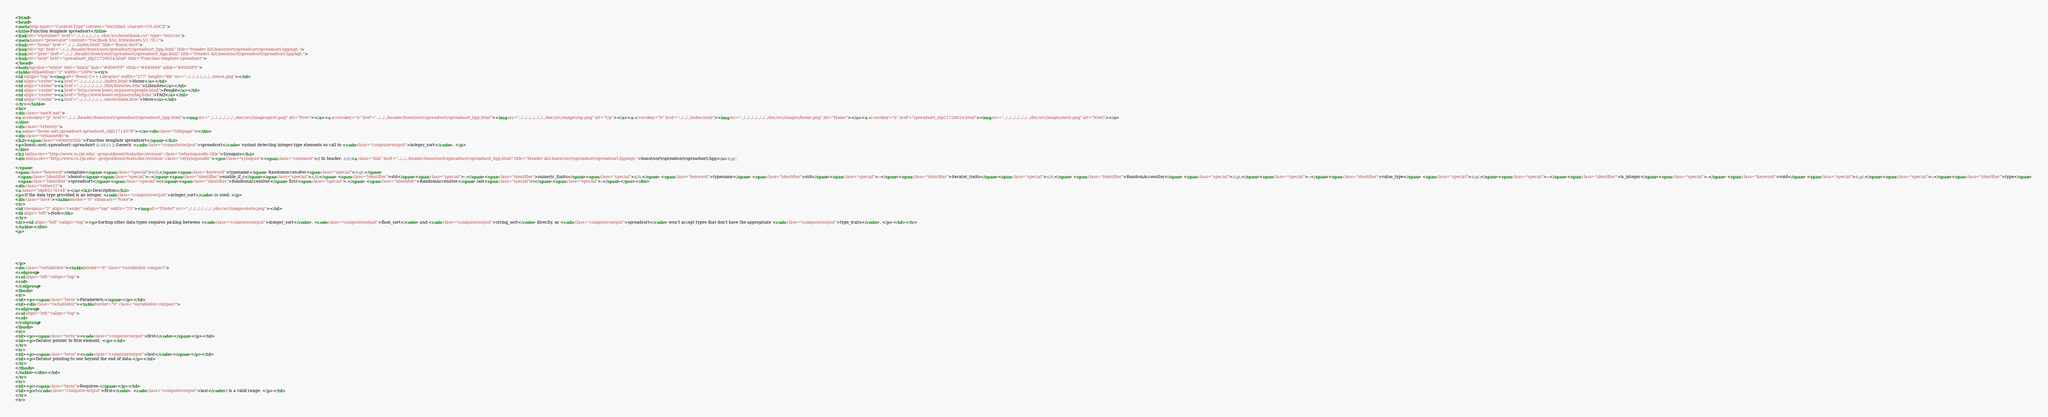Convert code to text. <code><loc_0><loc_0><loc_500><loc_500><_HTML_><html>
<head>
<meta http-equiv="Content-Type" content="text/html; charset=US-ASCII">
<title>Function template spreadsort</title>
<link rel="stylesheet" href="../../../../../../../doc/src/boostbook.css" type="text/css">
<meta name="generator" content="DocBook XSL Stylesheets V1.78.1">
<link rel="home" href="../../../index.html" title="Boost.Sort">
<link rel="up" href="../../../header/boost/sort/spreadsort/spreadsort_hpp.html" title="Header &lt;boost/sort/spreadsort/spreadsort.hpp&gt;">
<link rel="prev" href="../../../header/boost/sort/spreadsort/spreadsort_hpp.html" title="Header &lt;boost/sort/spreadsort/spreadsort.hpp&gt;">
<link rel="next" href="spreadsort_idp21729024.html" title="Function template spreadsort">
</head>
<body bgcolor="white" text="black" link="#0000FF" vlink="#840084" alink="#0000FF">
<table cellpadding="2" width="100%"><tr>
<td valign="top"><img alt="Boost C++ Libraries" width="277" height="86" src="../../../../../../../boost.png"></td>
<td align="center"><a href="../../../../../../../index.html">Home</a></td>
<td align="center"><a href="../../../../../../../libs/libraries.htm">Libraries</a></td>
<td align="center"><a href="http://www.boost.org/users/people.html">People</a></td>
<td align="center"><a href="http://www.boost.org/users/faq.html">FAQ</a></td>
<td align="center"><a href="../../../../../../../more/index.htm">More</a></td>
</tr></table>
<hr>
<div class="spirit-nav">
<a accesskey="p" href="../../../header/boost/sort/spreadsort/spreadsort_hpp.html"><img src="../../../../../../../doc/src/images/prev.png" alt="Prev"></a><a accesskey="u" href="../../../header/boost/sort/spreadsort/spreadsort_hpp.html"><img src="../../../../../../../doc/src/images/up.png" alt="Up"></a><a accesskey="h" href="../../../index.html"><img src="../../../../../../../doc/src/images/home.png" alt="Home"></a><a accesskey="n" href="spreadsort_idp21729024.html"><img src="../../../../../../../doc/src/images/next.png" alt="Next"></a>
</div>
<div class="refentry">
<a name="boost.sort.spreadsort.spreadsort_idp21714576"></a><div class="titlepage"></div>
<div class="refnamediv">
<h2><span class="refentrytitle">Function template spreadsort</span></h2>
<p>boost::sort::spreadsort::spreadsort &#8212; Generic <code class="computeroutput">spreadsort</code> variant detecting integer-type elements so call to <code class="computeroutput">integer_sort</code>. </p>
</div>
<h2 xmlns:rev="http://www.cs.rpi.edu/~gregod/boost/tools/doc/revision" class="refsynopsisdiv-title">Synopsis</h2>
<div xmlns:rev="http://www.cs.rpi.edu/~gregod/boost/tools/doc/revision" class="refsynopsisdiv"><pre class="synopsis"><span class="comment">// In header: &lt;<a class="link" href="../../../header/boost/sort/spreadsort/spreadsort_hpp.html" title="Header &lt;boost/sort/spreadsort/spreadsort.hpp&gt;">boost/sort/spreadsort/spreadsort.hpp</a>&gt;

</span>
<span class="keyword">template</span><span class="special">&lt;</span><span class="keyword">typename</span> RandomAccessIter<span class="special">&gt;</span> 
  <span class="identifier">boost</span><span class="special">::</span><span class="identifier">enable_if_c</span><span class="special">&lt;</span> <span class="identifier">std</span><span class="special">::</span><span class="identifier">numeric_limits</span><span class="special">&lt;</span> <span class="keyword">typename</span> <span class="identifier">std</span><span class="special">::</span><span class="identifier">iterator_traits</span><span class="special">&lt;</span> <span class="identifier">RandomAccessIter</span> <span class="special">&gt;</span><span class="special">::</span><span class="identifier">value_type</span> <span class="special">&gt;</span><span class="special">::</span><span class="identifier">is_integer</span><span class="special">,</span> <span class="keyword">void</span> <span class="special">&gt;</span><span class="special">::</span><span class="identifier">type</span> 
  <span class="identifier">spreadsort</span><span class="special">(</span><span class="identifier">RandomAccessIter</span> first<span class="special">,</span> <span class="identifier">RandomAccessIter</span> last<span class="special">)</span><span class="special">;</span></pre></div>
<div class="refsect1">
<a name="idp95174144"></a><h2>Description</h2>
<p>If the data type provided is an integer, <code class="computeroutput">integer_sort</code> is used. </p>
<div class="note"><table border="0" summary="Note">
<tr>
<td rowspan="2" align="center" valign="top" width="25"><img alt="[Note]" src="../../../../../../../doc/src/images/note.png"></td>
<th align="left">Note</th>
</tr>
<tr><td align="left" valign="top"><p>Sorting other data types requires picking between <code class="computeroutput">integer_sort</code>, <code class="computeroutput">float_sort</code> and <code class="computeroutput">string_sort</code> directly, as <code class="computeroutput">spreadsort</code> won't accept types that don't have the appropriate <code class="computeroutput">type_traits</code>. </p></td></tr>
</table></div>
<p>






</p>
<div class="variablelist"><table border="0" class="variablelist compact">
<colgroup>
<col align="left" valign="top">
<col>
</colgroup>
<tbody>
<tr>
<td><p><span class="term">Parameters:</span></p></td>
<td><div class="variablelist"><table border="0" class="variablelist compact">
<colgroup>
<col align="left" valign="top">
<col>
</colgroup>
<tbody>
<tr>
<td><p><span class="term"><code class="computeroutput">first</code></span></p></td>
<td><p>Iterator pointer to first element. </p></td>
</tr>
<tr>
<td><p><span class="term"><code class="computeroutput">last</code></span></p></td>
<td><p>Iterator pointing to one beyond the end of data.</p></td>
</tr>
</tbody>
</table></div></td>
</tr>
<tr>
<td><p><span class="term">Requires:</span></p></td>
<td><p>[<code class="computeroutput">first</code>, <code class="computeroutput">last</code>) is a valid range. </p></td>
</tr>
<tr></code> 